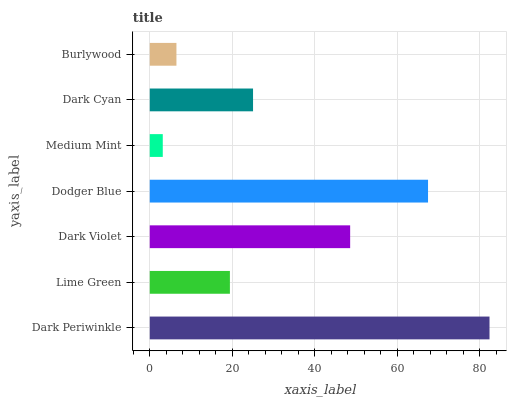Is Medium Mint the minimum?
Answer yes or no. Yes. Is Dark Periwinkle the maximum?
Answer yes or no. Yes. Is Lime Green the minimum?
Answer yes or no. No. Is Lime Green the maximum?
Answer yes or no. No. Is Dark Periwinkle greater than Lime Green?
Answer yes or no. Yes. Is Lime Green less than Dark Periwinkle?
Answer yes or no. Yes. Is Lime Green greater than Dark Periwinkle?
Answer yes or no. No. Is Dark Periwinkle less than Lime Green?
Answer yes or no. No. Is Dark Cyan the high median?
Answer yes or no. Yes. Is Dark Cyan the low median?
Answer yes or no. Yes. Is Dodger Blue the high median?
Answer yes or no. No. Is Dark Violet the low median?
Answer yes or no. No. 